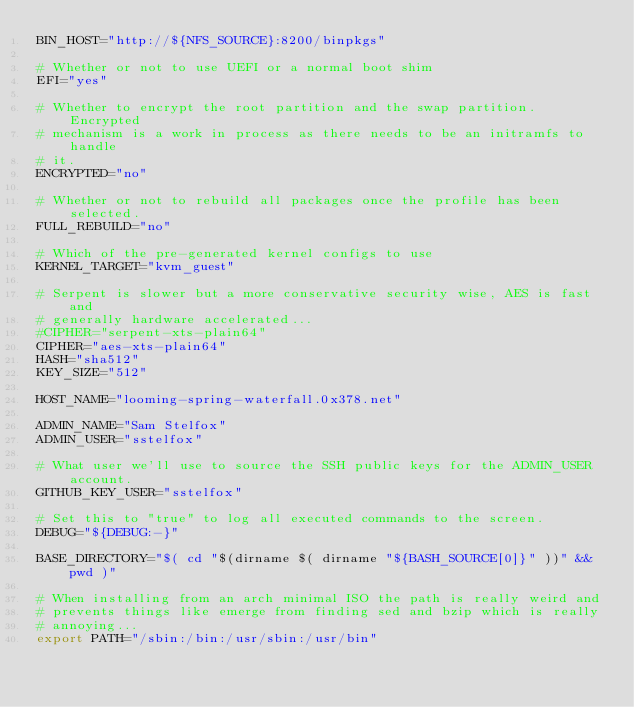<code> <loc_0><loc_0><loc_500><loc_500><_Bash_>BIN_HOST="http://${NFS_SOURCE}:8200/binpkgs"

# Whether or not to use UEFI or a normal boot shim
EFI="yes"

# Whether to encrypt the root partition and the swap partition. Encrypted
# mechanism is a work in process as there needs to be an initramfs to handle
# it.
ENCRYPTED="no"

# Whether or not to rebuild all packages once the profile has been selected.
FULL_REBUILD="no"

# Which of the pre-generated kernel configs to use
KERNEL_TARGET="kvm_guest"

# Serpent is slower but a more conservative security wise, AES is fast and
# generally hardware accelerated...
#CIPHER="serpent-xts-plain64"
CIPHER="aes-xts-plain64"
HASH="sha512"
KEY_SIZE="512"

HOST_NAME="looming-spring-waterfall.0x378.net"

ADMIN_NAME="Sam Stelfox"
ADMIN_USER="sstelfox"

# What user we'll use to source the SSH public keys for the ADMIN_USER account.
GITHUB_KEY_USER="sstelfox"

# Set this to "true" to log all executed commands to the screen.
DEBUG="${DEBUG:-}"

BASE_DIRECTORY="$( cd "$(dirname $( dirname "${BASH_SOURCE[0]}" ))" && pwd )"

# When installing from an arch minimal ISO the path is really weird and
# prevents things like emerge from finding sed and bzip which is really
# annoying...
export PATH="/sbin:/bin:/usr/sbin:/usr/bin"
</code> 